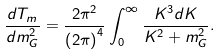Convert formula to latex. <formula><loc_0><loc_0><loc_500><loc_500>\frac { d T _ { m } } { d m _ { G } ^ { 2 } } = \frac { 2 \pi ^ { 2 } } { \left ( 2 \pi \right ) ^ { 4 } } \int _ { 0 } ^ { \infty } \frac { K ^ { 3 } d K } { K ^ { 2 } + m _ { G } ^ { 2 } } .</formula> 